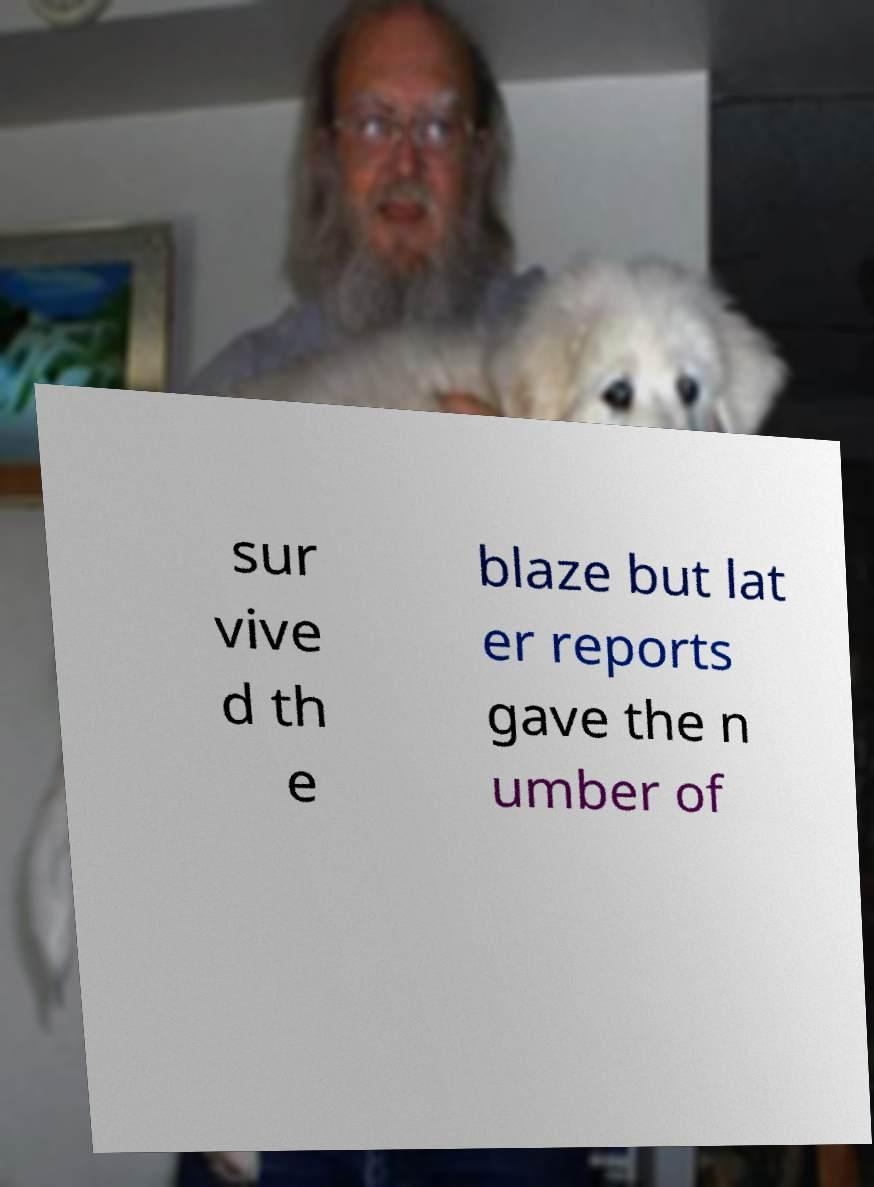Can you accurately transcribe the text from the provided image for me? sur vive d th e blaze but lat er reports gave the n umber of 